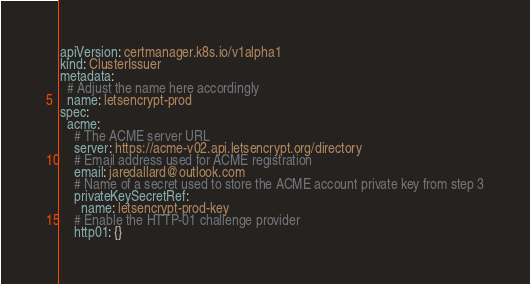<code> <loc_0><loc_0><loc_500><loc_500><_YAML_>apiVersion: certmanager.k8s.io/v1alpha1
kind: ClusterIssuer
metadata:
  # Adjust the name here accordingly
  name: letsencrypt-prod
spec:
  acme:
    # The ACME server URL
    server: https://acme-v02.api.letsencrypt.org/directory
    # Email address used for ACME registration
    email: jaredallard@outlook.com
    # Name of a secret used to store the ACME account private key from step 3
    privateKeySecretRef:
      name: letsencrypt-prod-key
    # Enable the HTTP-01 challenge provider
    http01: {}
</code> 